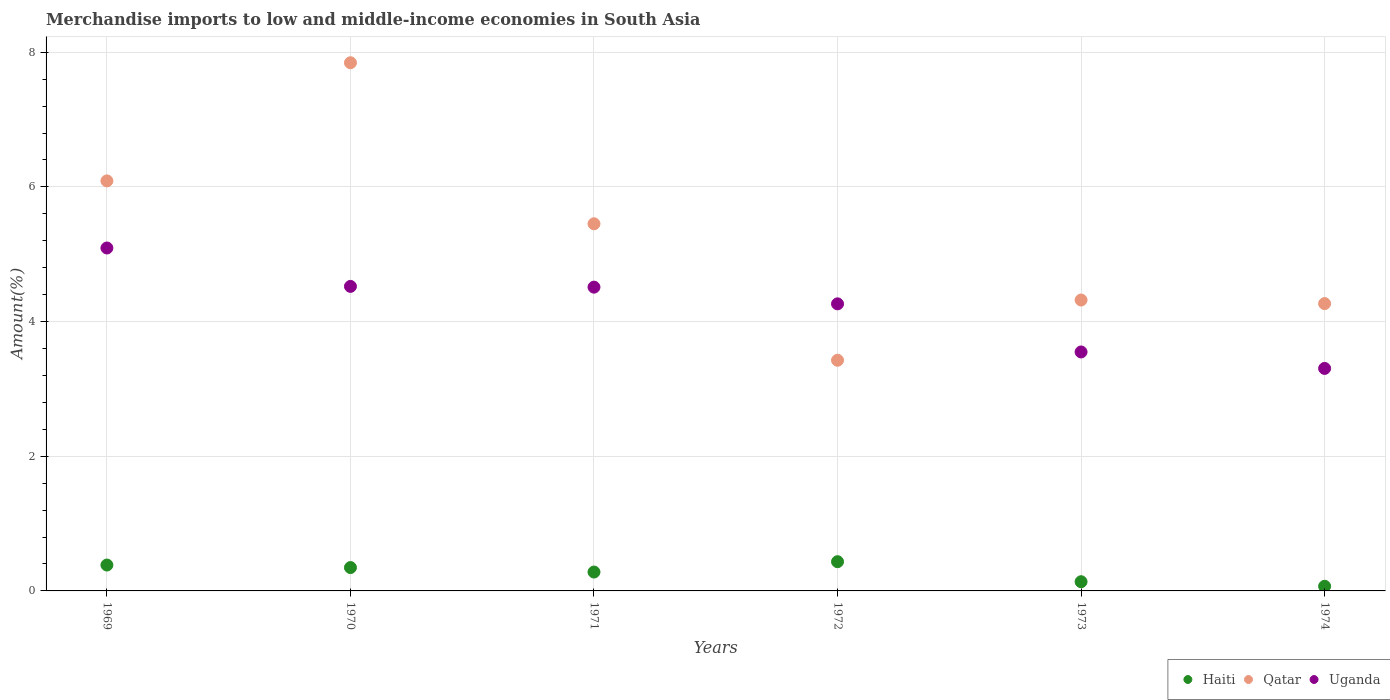What is the percentage of amount earned from merchandise imports in Uganda in 1970?
Your answer should be very brief. 4.52. Across all years, what is the maximum percentage of amount earned from merchandise imports in Uganda?
Your response must be concise. 5.09. Across all years, what is the minimum percentage of amount earned from merchandise imports in Qatar?
Offer a terse response. 3.43. In which year was the percentage of amount earned from merchandise imports in Uganda minimum?
Your answer should be compact. 1974. What is the total percentage of amount earned from merchandise imports in Qatar in the graph?
Your answer should be compact. 31.4. What is the difference between the percentage of amount earned from merchandise imports in Qatar in 1971 and that in 1972?
Keep it short and to the point. 2.03. What is the difference between the percentage of amount earned from merchandise imports in Haiti in 1971 and the percentage of amount earned from merchandise imports in Uganda in 1974?
Keep it short and to the point. -3.02. What is the average percentage of amount earned from merchandise imports in Qatar per year?
Your answer should be compact. 5.23. In the year 1973, what is the difference between the percentage of amount earned from merchandise imports in Uganda and percentage of amount earned from merchandise imports in Qatar?
Offer a very short reply. -0.77. What is the ratio of the percentage of amount earned from merchandise imports in Uganda in 1970 to that in 1973?
Provide a short and direct response. 1.27. Is the percentage of amount earned from merchandise imports in Uganda in 1970 less than that in 1974?
Your answer should be very brief. No. Is the difference between the percentage of amount earned from merchandise imports in Uganda in 1969 and 1973 greater than the difference between the percentage of amount earned from merchandise imports in Qatar in 1969 and 1973?
Ensure brevity in your answer.  No. What is the difference between the highest and the second highest percentage of amount earned from merchandise imports in Qatar?
Provide a succinct answer. 1.75. What is the difference between the highest and the lowest percentage of amount earned from merchandise imports in Uganda?
Offer a terse response. 1.79. In how many years, is the percentage of amount earned from merchandise imports in Haiti greater than the average percentage of amount earned from merchandise imports in Haiti taken over all years?
Provide a short and direct response. 4. Is the sum of the percentage of amount earned from merchandise imports in Uganda in 1972 and 1973 greater than the maximum percentage of amount earned from merchandise imports in Haiti across all years?
Your answer should be very brief. Yes. Does the percentage of amount earned from merchandise imports in Qatar monotonically increase over the years?
Your answer should be very brief. No. Is the percentage of amount earned from merchandise imports in Uganda strictly greater than the percentage of amount earned from merchandise imports in Qatar over the years?
Offer a terse response. No. What is the difference between two consecutive major ticks on the Y-axis?
Ensure brevity in your answer.  2. Does the graph contain grids?
Give a very brief answer. Yes. What is the title of the graph?
Make the answer very short. Merchandise imports to low and middle-income economies in South Asia. What is the label or title of the Y-axis?
Give a very brief answer. Amount(%). What is the Amount(%) of Haiti in 1969?
Offer a very short reply. 0.38. What is the Amount(%) of Qatar in 1969?
Your answer should be very brief. 6.09. What is the Amount(%) of Uganda in 1969?
Make the answer very short. 5.09. What is the Amount(%) in Haiti in 1970?
Offer a very short reply. 0.35. What is the Amount(%) in Qatar in 1970?
Ensure brevity in your answer.  7.84. What is the Amount(%) in Uganda in 1970?
Offer a very short reply. 4.52. What is the Amount(%) of Haiti in 1971?
Offer a very short reply. 0.28. What is the Amount(%) in Qatar in 1971?
Provide a short and direct response. 5.45. What is the Amount(%) in Uganda in 1971?
Offer a very short reply. 4.51. What is the Amount(%) of Haiti in 1972?
Your answer should be compact. 0.43. What is the Amount(%) in Qatar in 1972?
Make the answer very short. 3.43. What is the Amount(%) in Uganda in 1972?
Make the answer very short. 4.26. What is the Amount(%) of Haiti in 1973?
Give a very brief answer. 0.14. What is the Amount(%) in Qatar in 1973?
Your response must be concise. 4.32. What is the Amount(%) of Uganda in 1973?
Provide a short and direct response. 3.55. What is the Amount(%) in Haiti in 1974?
Your answer should be very brief. 0.07. What is the Amount(%) in Qatar in 1974?
Provide a succinct answer. 4.27. What is the Amount(%) of Uganda in 1974?
Your answer should be very brief. 3.3. Across all years, what is the maximum Amount(%) in Haiti?
Your answer should be compact. 0.43. Across all years, what is the maximum Amount(%) in Qatar?
Your response must be concise. 7.84. Across all years, what is the maximum Amount(%) of Uganda?
Ensure brevity in your answer.  5.09. Across all years, what is the minimum Amount(%) of Haiti?
Your answer should be very brief. 0.07. Across all years, what is the minimum Amount(%) in Qatar?
Give a very brief answer. 3.43. Across all years, what is the minimum Amount(%) in Uganda?
Your answer should be very brief. 3.3. What is the total Amount(%) in Haiti in the graph?
Ensure brevity in your answer.  1.65. What is the total Amount(%) of Qatar in the graph?
Keep it short and to the point. 31.4. What is the total Amount(%) of Uganda in the graph?
Ensure brevity in your answer.  25.24. What is the difference between the Amount(%) of Haiti in 1969 and that in 1970?
Your response must be concise. 0.04. What is the difference between the Amount(%) in Qatar in 1969 and that in 1970?
Keep it short and to the point. -1.75. What is the difference between the Amount(%) of Uganda in 1969 and that in 1970?
Keep it short and to the point. 0.57. What is the difference between the Amount(%) of Haiti in 1969 and that in 1971?
Your response must be concise. 0.1. What is the difference between the Amount(%) in Qatar in 1969 and that in 1971?
Ensure brevity in your answer.  0.64. What is the difference between the Amount(%) in Uganda in 1969 and that in 1971?
Provide a short and direct response. 0.58. What is the difference between the Amount(%) in Haiti in 1969 and that in 1972?
Your answer should be very brief. -0.05. What is the difference between the Amount(%) in Qatar in 1969 and that in 1972?
Give a very brief answer. 2.66. What is the difference between the Amount(%) in Uganda in 1969 and that in 1972?
Provide a succinct answer. 0.83. What is the difference between the Amount(%) in Haiti in 1969 and that in 1973?
Your answer should be very brief. 0.25. What is the difference between the Amount(%) of Qatar in 1969 and that in 1973?
Make the answer very short. 1.77. What is the difference between the Amount(%) of Uganda in 1969 and that in 1973?
Offer a terse response. 1.54. What is the difference between the Amount(%) in Haiti in 1969 and that in 1974?
Offer a very short reply. 0.32. What is the difference between the Amount(%) in Qatar in 1969 and that in 1974?
Give a very brief answer. 1.82. What is the difference between the Amount(%) of Uganda in 1969 and that in 1974?
Provide a short and direct response. 1.79. What is the difference between the Amount(%) in Haiti in 1970 and that in 1971?
Your answer should be very brief. 0.07. What is the difference between the Amount(%) in Qatar in 1970 and that in 1971?
Provide a succinct answer. 2.39. What is the difference between the Amount(%) in Uganda in 1970 and that in 1971?
Provide a short and direct response. 0.01. What is the difference between the Amount(%) in Haiti in 1970 and that in 1972?
Your response must be concise. -0.09. What is the difference between the Amount(%) of Qatar in 1970 and that in 1972?
Your response must be concise. 4.42. What is the difference between the Amount(%) of Uganda in 1970 and that in 1972?
Provide a short and direct response. 0.26. What is the difference between the Amount(%) in Haiti in 1970 and that in 1973?
Make the answer very short. 0.21. What is the difference between the Amount(%) of Qatar in 1970 and that in 1973?
Make the answer very short. 3.52. What is the difference between the Amount(%) of Uganda in 1970 and that in 1973?
Offer a very short reply. 0.97. What is the difference between the Amount(%) in Haiti in 1970 and that in 1974?
Provide a short and direct response. 0.28. What is the difference between the Amount(%) in Qatar in 1970 and that in 1974?
Keep it short and to the point. 3.58. What is the difference between the Amount(%) in Uganda in 1970 and that in 1974?
Give a very brief answer. 1.22. What is the difference between the Amount(%) of Haiti in 1971 and that in 1972?
Give a very brief answer. -0.15. What is the difference between the Amount(%) in Qatar in 1971 and that in 1972?
Ensure brevity in your answer.  2.03. What is the difference between the Amount(%) of Uganda in 1971 and that in 1972?
Your answer should be compact. 0.25. What is the difference between the Amount(%) in Haiti in 1971 and that in 1973?
Provide a short and direct response. 0.14. What is the difference between the Amount(%) in Qatar in 1971 and that in 1973?
Your answer should be compact. 1.13. What is the difference between the Amount(%) of Uganda in 1971 and that in 1973?
Keep it short and to the point. 0.96. What is the difference between the Amount(%) of Haiti in 1971 and that in 1974?
Your answer should be very brief. 0.21. What is the difference between the Amount(%) of Qatar in 1971 and that in 1974?
Make the answer very short. 1.19. What is the difference between the Amount(%) of Uganda in 1971 and that in 1974?
Ensure brevity in your answer.  1.21. What is the difference between the Amount(%) in Haiti in 1972 and that in 1973?
Ensure brevity in your answer.  0.3. What is the difference between the Amount(%) in Qatar in 1972 and that in 1973?
Make the answer very short. -0.89. What is the difference between the Amount(%) in Uganda in 1972 and that in 1973?
Keep it short and to the point. 0.71. What is the difference between the Amount(%) in Haiti in 1972 and that in 1974?
Provide a succinct answer. 0.37. What is the difference between the Amount(%) of Qatar in 1972 and that in 1974?
Provide a succinct answer. -0.84. What is the difference between the Amount(%) of Uganda in 1972 and that in 1974?
Ensure brevity in your answer.  0.96. What is the difference between the Amount(%) of Haiti in 1973 and that in 1974?
Provide a succinct answer. 0.07. What is the difference between the Amount(%) in Qatar in 1973 and that in 1974?
Keep it short and to the point. 0.05. What is the difference between the Amount(%) of Uganda in 1973 and that in 1974?
Your answer should be compact. 0.24. What is the difference between the Amount(%) in Haiti in 1969 and the Amount(%) in Qatar in 1970?
Give a very brief answer. -7.46. What is the difference between the Amount(%) in Haiti in 1969 and the Amount(%) in Uganda in 1970?
Offer a terse response. -4.14. What is the difference between the Amount(%) of Qatar in 1969 and the Amount(%) of Uganda in 1970?
Your answer should be compact. 1.57. What is the difference between the Amount(%) in Haiti in 1969 and the Amount(%) in Qatar in 1971?
Provide a succinct answer. -5.07. What is the difference between the Amount(%) in Haiti in 1969 and the Amount(%) in Uganda in 1971?
Provide a succinct answer. -4.13. What is the difference between the Amount(%) of Qatar in 1969 and the Amount(%) of Uganda in 1971?
Give a very brief answer. 1.58. What is the difference between the Amount(%) of Haiti in 1969 and the Amount(%) of Qatar in 1972?
Offer a terse response. -3.04. What is the difference between the Amount(%) in Haiti in 1969 and the Amount(%) in Uganda in 1972?
Provide a short and direct response. -3.88. What is the difference between the Amount(%) of Qatar in 1969 and the Amount(%) of Uganda in 1972?
Provide a short and direct response. 1.83. What is the difference between the Amount(%) of Haiti in 1969 and the Amount(%) of Qatar in 1973?
Make the answer very short. -3.94. What is the difference between the Amount(%) in Haiti in 1969 and the Amount(%) in Uganda in 1973?
Ensure brevity in your answer.  -3.16. What is the difference between the Amount(%) of Qatar in 1969 and the Amount(%) of Uganda in 1973?
Make the answer very short. 2.54. What is the difference between the Amount(%) of Haiti in 1969 and the Amount(%) of Qatar in 1974?
Ensure brevity in your answer.  -3.88. What is the difference between the Amount(%) of Haiti in 1969 and the Amount(%) of Uganda in 1974?
Keep it short and to the point. -2.92. What is the difference between the Amount(%) of Qatar in 1969 and the Amount(%) of Uganda in 1974?
Your answer should be very brief. 2.78. What is the difference between the Amount(%) of Haiti in 1970 and the Amount(%) of Qatar in 1971?
Ensure brevity in your answer.  -5.11. What is the difference between the Amount(%) in Haiti in 1970 and the Amount(%) in Uganda in 1971?
Give a very brief answer. -4.16. What is the difference between the Amount(%) in Qatar in 1970 and the Amount(%) in Uganda in 1971?
Your answer should be compact. 3.33. What is the difference between the Amount(%) in Haiti in 1970 and the Amount(%) in Qatar in 1972?
Your response must be concise. -3.08. What is the difference between the Amount(%) in Haiti in 1970 and the Amount(%) in Uganda in 1972?
Provide a short and direct response. -3.92. What is the difference between the Amount(%) of Qatar in 1970 and the Amount(%) of Uganda in 1972?
Ensure brevity in your answer.  3.58. What is the difference between the Amount(%) in Haiti in 1970 and the Amount(%) in Qatar in 1973?
Ensure brevity in your answer.  -3.97. What is the difference between the Amount(%) of Haiti in 1970 and the Amount(%) of Uganda in 1973?
Offer a very short reply. -3.2. What is the difference between the Amount(%) of Qatar in 1970 and the Amount(%) of Uganda in 1973?
Provide a short and direct response. 4.29. What is the difference between the Amount(%) of Haiti in 1970 and the Amount(%) of Qatar in 1974?
Offer a very short reply. -3.92. What is the difference between the Amount(%) of Haiti in 1970 and the Amount(%) of Uganda in 1974?
Give a very brief answer. -2.96. What is the difference between the Amount(%) of Qatar in 1970 and the Amount(%) of Uganda in 1974?
Offer a very short reply. 4.54. What is the difference between the Amount(%) in Haiti in 1971 and the Amount(%) in Qatar in 1972?
Provide a succinct answer. -3.15. What is the difference between the Amount(%) of Haiti in 1971 and the Amount(%) of Uganda in 1972?
Your answer should be very brief. -3.98. What is the difference between the Amount(%) in Qatar in 1971 and the Amount(%) in Uganda in 1972?
Keep it short and to the point. 1.19. What is the difference between the Amount(%) of Haiti in 1971 and the Amount(%) of Qatar in 1973?
Offer a terse response. -4.04. What is the difference between the Amount(%) in Haiti in 1971 and the Amount(%) in Uganda in 1973?
Ensure brevity in your answer.  -3.27. What is the difference between the Amount(%) in Qatar in 1971 and the Amount(%) in Uganda in 1973?
Offer a terse response. 1.9. What is the difference between the Amount(%) of Haiti in 1971 and the Amount(%) of Qatar in 1974?
Provide a short and direct response. -3.99. What is the difference between the Amount(%) in Haiti in 1971 and the Amount(%) in Uganda in 1974?
Offer a very short reply. -3.02. What is the difference between the Amount(%) in Qatar in 1971 and the Amount(%) in Uganda in 1974?
Ensure brevity in your answer.  2.15. What is the difference between the Amount(%) of Haiti in 1972 and the Amount(%) of Qatar in 1973?
Ensure brevity in your answer.  -3.89. What is the difference between the Amount(%) in Haiti in 1972 and the Amount(%) in Uganda in 1973?
Provide a succinct answer. -3.11. What is the difference between the Amount(%) in Qatar in 1972 and the Amount(%) in Uganda in 1973?
Give a very brief answer. -0.12. What is the difference between the Amount(%) of Haiti in 1972 and the Amount(%) of Qatar in 1974?
Make the answer very short. -3.83. What is the difference between the Amount(%) of Haiti in 1972 and the Amount(%) of Uganda in 1974?
Provide a short and direct response. -2.87. What is the difference between the Amount(%) of Qatar in 1972 and the Amount(%) of Uganda in 1974?
Your answer should be compact. 0.12. What is the difference between the Amount(%) of Haiti in 1973 and the Amount(%) of Qatar in 1974?
Your answer should be very brief. -4.13. What is the difference between the Amount(%) of Haiti in 1973 and the Amount(%) of Uganda in 1974?
Offer a very short reply. -3.17. What is the difference between the Amount(%) in Qatar in 1973 and the Amount(%) in Uganda in 1974?
Your answer should be compact. 1.02. What is the average Amount(%) of Haiti per year?
Your response must be concise. 0.28. What is the average Amount(%) of Qatar per year?
Make the answer very short. 5.23. What is the average Amount(%) in Uganda per year?
Make the answer very short. 4.21. In the year 1969, what is the difference between the Amount(%) in Haiti and Amount(%) in Qatar?
Make the answer very short. -5.7. In the year 1969, what is the difference between the Amount(%) in Haiti and Amount(%) in Uganda?
Your answer should be compact. -4.71. In the year 1969, what is the difference between the Amount(%) in Qatar and Amount(%) in Uganda?
Your response must be concise. 1. In the year 1970, what is the difference between the Amount(%) in Haiti and Amount(%) in Qatar?
Give a very brief answer. -7.5. In the year 1970, what is the difference between the Amount(%) in Haiti and Amount(%) in Uganda?
Ensure brevity in your answer.  -4.18. In the year 1970, what is the difference between the Amount(%) of Qatar and Amount(%) of Uganda?
Your answer should be compact. 3.32. In the year 1971, what is the difference between the Amount(%) in Haiti and Amount(%) in Qatar?
Offer a terse response. -5.17. In the year 1971, what is the difference between the Amount(%) of Haiti and Amount(%) of Uganda?
Your response must be concise. -4.23. In the year 1971, what is the difference between the Amount(%) of Qatar and Amount(%) of Uganda?
Make the answer very short. 0.94. In the year 1972, what is the difference between the Amount(%) in Haiti and Amount(%) in Qatar?
Provide a short and direct response. -2.99. In the year 1972, what is the difference between the Amount(%) of Haiti and Amount(%) of Uganda?
Your answer should be very brief. -3.83. In the year 1972, what is the difference between the Amount(%) in Qatar and Amount(%) in Uganda?
Ensure brevity in your answer.  -0.84. In the year 1973, what is the difference between the Amount(%) of Haiti and Amount(%) of Qatar?
Offer a very short reply. -4.18. In the year 1973, what is the difference between the Amount(%) of Haiti and Amount(%) of Uganda?
Offer a very short reply. -3.41. In the year 1973, what is the difference between the Amount(%) of Qatar and Amount(%) of Uganda?
Your response must be concise. 0.77. In the year 1974, what is the difference between the Amount(%) in Haiti and Amount(%) in Qatar?
Your response must be concise. -4.2. In the year 1974, what is the difference between the Amount(%) of Haiti and Amount(%) of Uganda?
Offer a very short reply. -3.24. In the year 1974, what is the difference between the Amount(%) in Qatar and Amount(%) in Uganda?
Offer a very short reply. 0.96. What is the ratio of the Amount(%) in Haiti in 1969 to that in 1970?
Offer a very short reply. 1.11. What is the ratio of the Amount(%) of Qatar in 1969 to that in 1970?
Provide a short and direct response. 0.78. What is the ratio of the Amount(%) of Uganda in 1969 to that in 1970?
Keep it short and to the point. 1.13. What is the ratio of the Amount(%) of Haiti in 1969 to that in 1971?
Offer a terse response. 1.37. What is the ratio of the Amount(%) of Qatar in 1969 to that in 1971?
Your response must be concise. 1.12. What is the ratio of the Amount(%) of Uganda in 1969 to that in 1971?
Offer a terse response. 1.13. What is the ratio of the Amount(%) in Haiti in 1969 to that in 1972?
Offer a very short reply. 0.89. What is the ratio of the Amount(%) in Qatar in 1969 to that in 1972?
Your answer should be compact. 1.78. What is the ratio of the Amount(%) in Uganda in 1969 to that in 1972?
Ensure brevity in your answer.  1.19. What is the ratio of the Amount(%) of Haiti in 1969 to that in 1973?
Your answer should be compact. 2.81. What is the ratio of the Amount(%) in Qatar in 1969 to that in 1973?
Your response must be concise. 1.41. What is the ratio of the Amount(%) in Uganda in 1969 to that in 1973?
Give a very brief answer. 1.44. What is the ratio of the Amount(%) of Haiti in 1969 to that in 1974?
Your response must be concise. 5.57. What is the ratio of the Amount(%) in Qatar in 1969 to that in 1974?
Offer a terse response. 1.43. What is the ratio of the Amount(%) in Uganda in 1969 to that in 1974?
Ensure brevity in your answer.  1.54. What is the ratio of the Amount(%) of Haiti in 1970 to that in 1971?
Your response must be concise. 1.24. What is the ratio of the Amount(%) of Qatar in 1970 to that in 1971?
Ensure brevity in your answer.  1.44. What is the ratio of the Amount(%) of Haiti in 1970 to that in 1972?
Give a very brief answer. 0.8. What is the ratio of the Amount(%) in Qatar in 1970 to that in 1972?
Offer a very short reply. 2.29. What is the ratio of the Amount(%) of Uganda in 1970 to that in 1972?
Your response must be concise. 1.06. What is the ratio of the Amount(%) of Haiti in 1970 to that in 1973?
Keep it short and to the point. 2.54. What is the ratio of the Amount(%) of Qatar in 1970 to that in 1973?
Keep it short and to the point. 1.82. What is the ratio of the Amount(%) of Uganda in 1970 to that in 1973?
Offer a very short reply. 1.27. What is the ratio of the Amount(%) in Haiti in 1970 to that in 1974?
Give a very brief answer. 5.03. What is the ratio of the Amount(%) in Qatar in 1970 to that in 1974?
Give a very brief answer. 1.84. What is the ratio of the Amount(%) of Uganda in 1970 to that in 1974?
Keep it short and to the point. 1.37. What is the ratio of the Amount(%) in Haiti in 1971 to that in 1972?
Provide a short and direct response. 0.65. What is the ratio of the Amount(%) of Qatar in 1971 to that in 1972?
Offer a very short reply. 1.59. What is the ratio of the Amount(%) of Uganda in 1971 to that in 1972?
Keep it short and to the point. 1.06. What is the ratio of the Amount(%) of Haiti in 1971 to that in 1973?
Your response must be concise. 2.05. What is the ratio of the Amount(%) in Qatar in 1971 to that in 1973?
Provide a short and direct response. 1.26. What is the ratio of the Amount(%) of Uganda in 1971 to that in 1973?
Your answer should be very brief. 1.27. What is the ratio of the Amount(%) of Haiti in 1971 to that in 1974?
Offer a terse response. 4.06. What is the ratio of the Amount(%) of Qatar in 1971 to that in 1974?
Offer a terse response. 1.28. What is the ratio of the Amount(%) in Uganda in 1971 to that in 1974?
Your answer should be compact. 1.37. What is the ratio of the Amount(%) of Haiti in 1972 to that in 1973?
Your answer should be compact. 3.18. What is the ratio of the Amount(%) in Qatar in 1972 to that in 1973?
Offer a very short reply. 0.79. What is the ratio of the Amount(%) in Uganda in 1972 to that in 1973?
Provide a succinct answer. 1.2. What is the ratio of the Amount(%) of Haiti in 1972 to that in 1974?
Your answer should be very brief. 6.29. What is the ratio of the Amount(%) in Qatar in 1972 to that in 1974?
Provide a short and direct response. 0.8. What is the ratio of the Amount(%) of Uganda in 1972 to that in 1974?
Your response must be concise. 1.29. What is the ratio of the Amount(%) in Haiti in 1973 to that in 1974?
Offer a terse response. 1.98. What is the ratio of the Amount(%) in Qatar in 1973 to that in 1974?
Offer a terse response. 1.01. What is the ratio of the Amount(%) of Uganda in 1973 to that in 1974?
Give a very brief answer. 1.07. What is the difference between the highest and the second highest Amount(%) of Haiti?
Provide a short and direct response. 0.05. What is the difference between the highest and the second highest Amount(%) of Qatar?
Provide a succinct answer. 1.75. What is the difference between the highest and the second highest Amount(%) in Uganda?
Give a very brief answer. 0.57. What is the difference between the highest and the lowest Amount(%) in Haiti?
Your response must be concise. 0.37. What is the difference between the highest and the lowest Amount(%) in Qatar?
Offer a terse response. 4.42. What is the difference between the highest and the lowest Amount(%) of Uganda?
Ensure brevity in your answer.  1.79. 